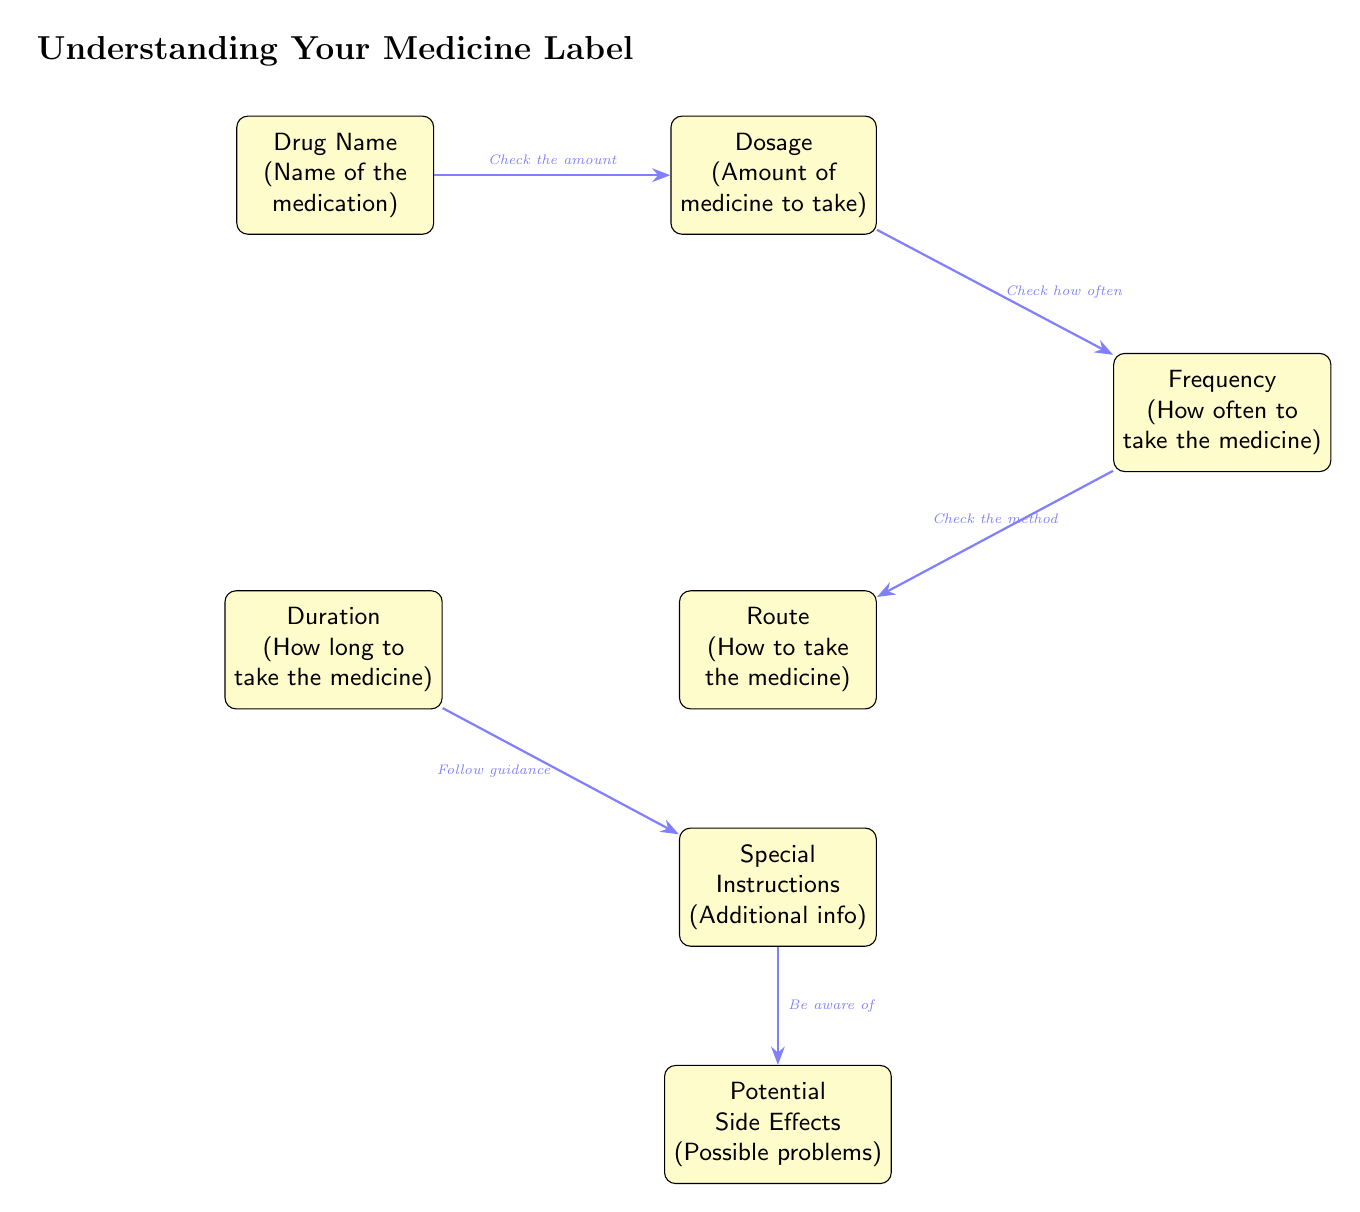What is the first box in the diagram? The first box in the diagram is labeled "Drug Name" and contains the description "(Name of the medication)."
Answer: Drug Name What does the "Frequency" box describe? The "Frequency" box describes "How often to take the medicine," as indicated in the diagram.
Answer: How often to take the medicine How many boxes are in the diagram? There are six boxes in the diagram representing different aspects of a medical prescription label.
Answer: 6 What is the relationship between "Dosage" and "Frequency"? The relationship is indicated by an arrow showing that one should "Check how often" to take the medicine after determining the dosage.
Answer: Check how often What does the "Route" box explain? The "Route" box explains "How to take the medicine," as specified in the diagram's description.
Answer: How to take the medicine What should you follow while considering the "Duration"? The diagram indicates that you should "Follow guidance" regarding the duration of medication.
Answer: Follow guidance Which box provides information about problems one might face? The box that provides this information is labeled "Potential Side Effects" and describes "Possible problems."
Answer: Potential Side Effects What flows from "Instructions" to "Side Effects"? The flow indicates that you should "Be aware of" the potential side effects stemming from the special instructions.
Answer: Be aware of How do "Drug Name" and "Dosage" connect? The connection is represented by an arrow indicating the step to "Check the amount" of medicine after identifying the drug name.
Answer: Check the amount 